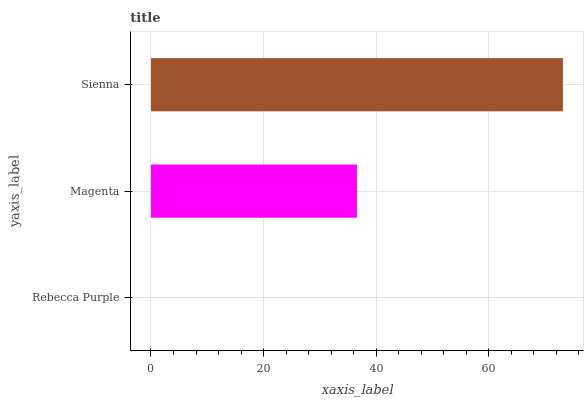Is Rebecca Purple the minimum?
Answer yes or no. Yes. Is Sienna the maximum?
Answer yes or no. Yes. Is Magenta the minimum?
Answer yes or no. No. Is Magenta the maximum?
Answer yes or no. No. Is Magenta greater than Rebecca Purple?
Answer yes or no. Yes. Is Rebecca Purple less than Magenta?
Answer yes or no. Yes. Is Rebecca Purple greater than Magenta?
Answer yes or no. No. Is Magenta less than Rebecca Purple?
Answer yes or no. No. Is Magenta the high median?
Answer yes or no. Yes. Is Magenta the low median?
Answer yes or no. Yes. Is Sienna the high median?
Answer yes or no. No. Is Rebecca Purple the low median?
Answer yes or no. No. 